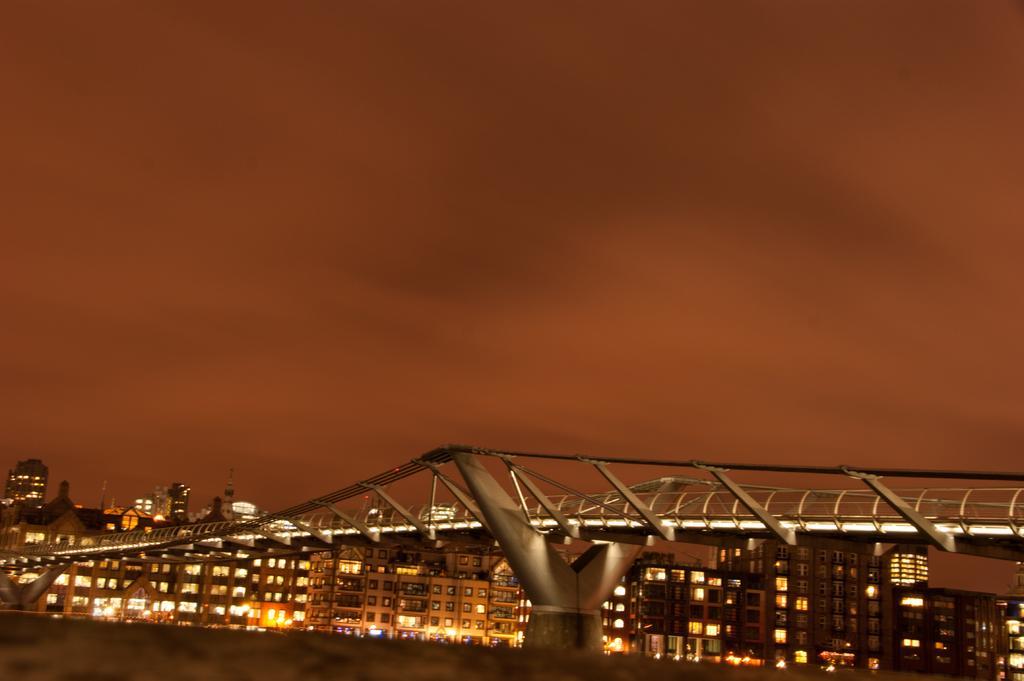Please provide a concise description of this image. At the bottom of the picture, we see the road. In the middle, we see a bridge. There are buildings, towers, lights and poles in the background. At the top, we see the sky. This picture might be clicked in the dark. 